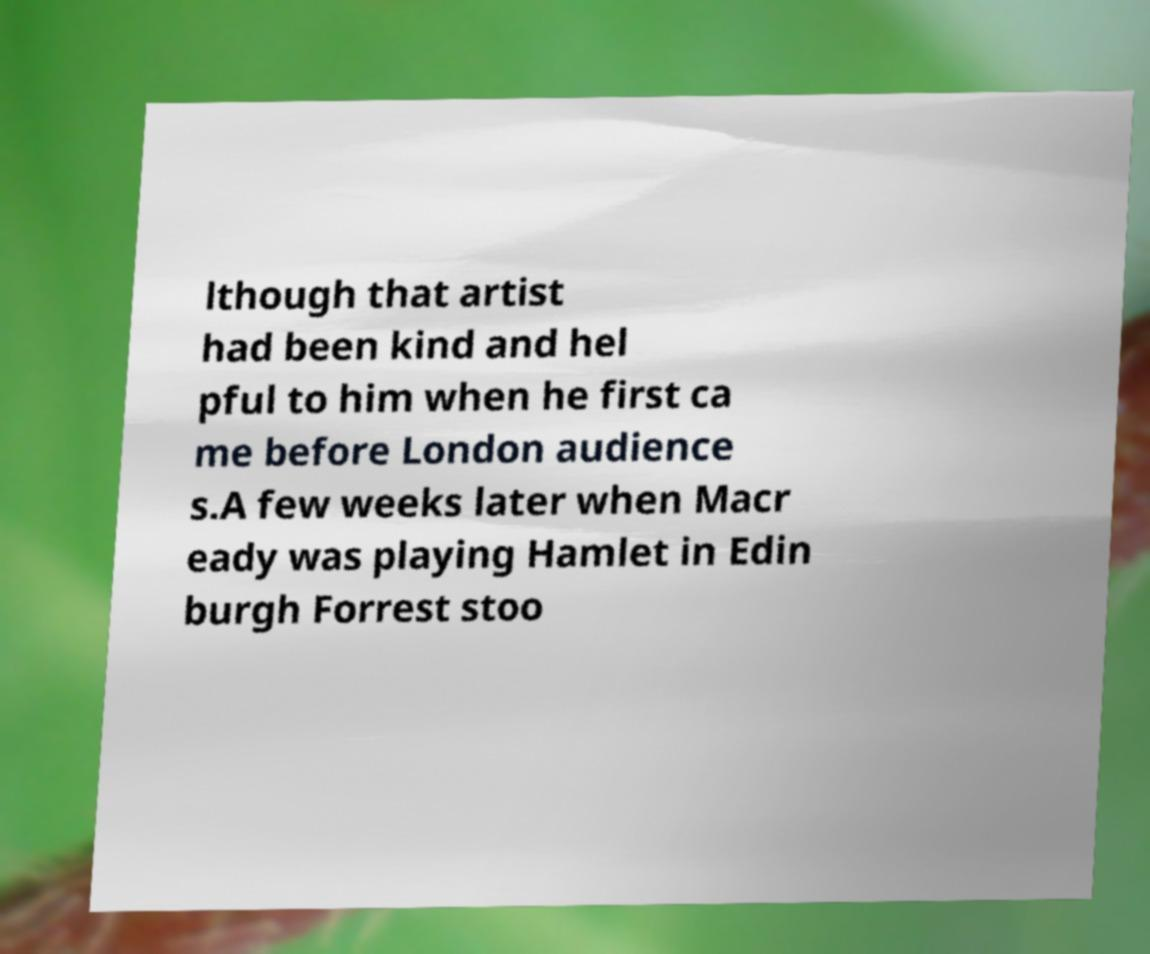There's text embedded in this image that I need extracted. Can you transcribe it verbatim? lthough that artist had been kind and hel pful to him when he first ca me before London audience s.A few weeks later when Macr eady was playing Hamlet in Edin burgh Forrest stoo 